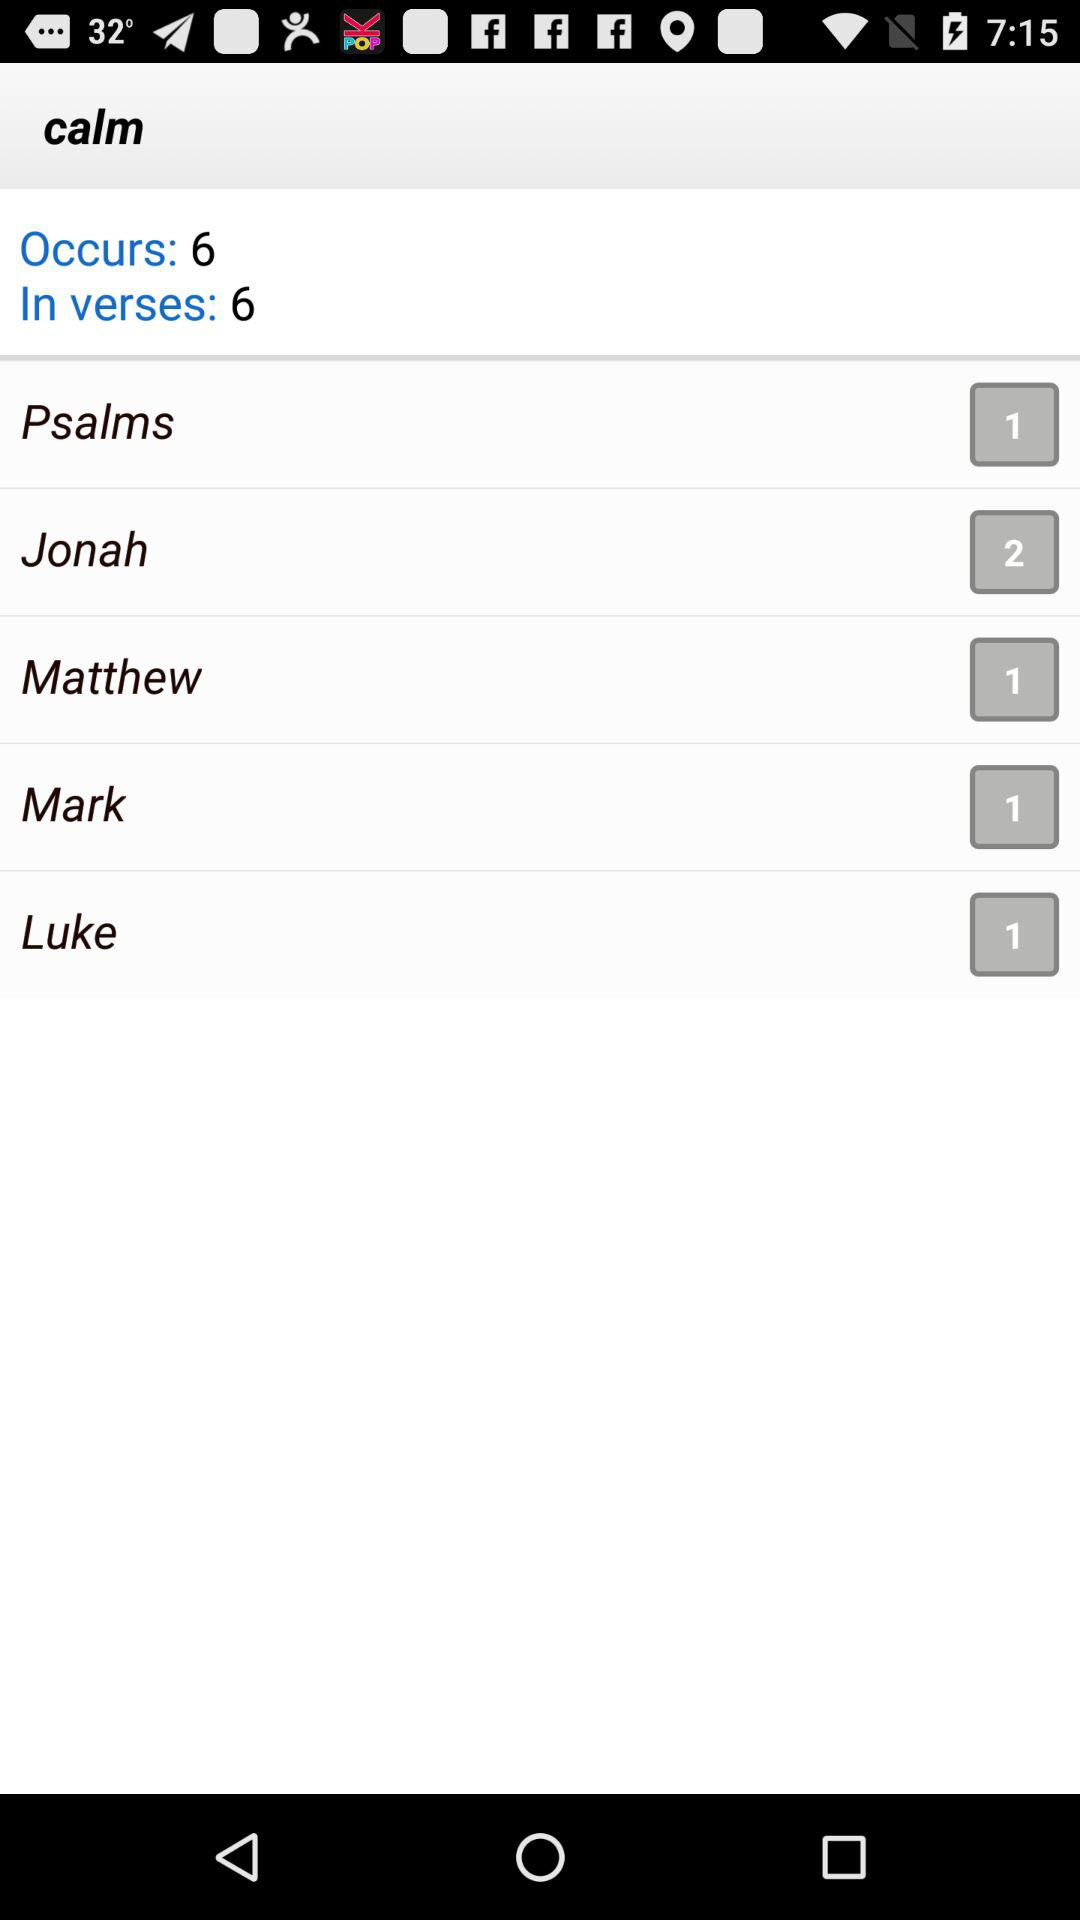What is the total number of "In verses"? The total number is 6. 